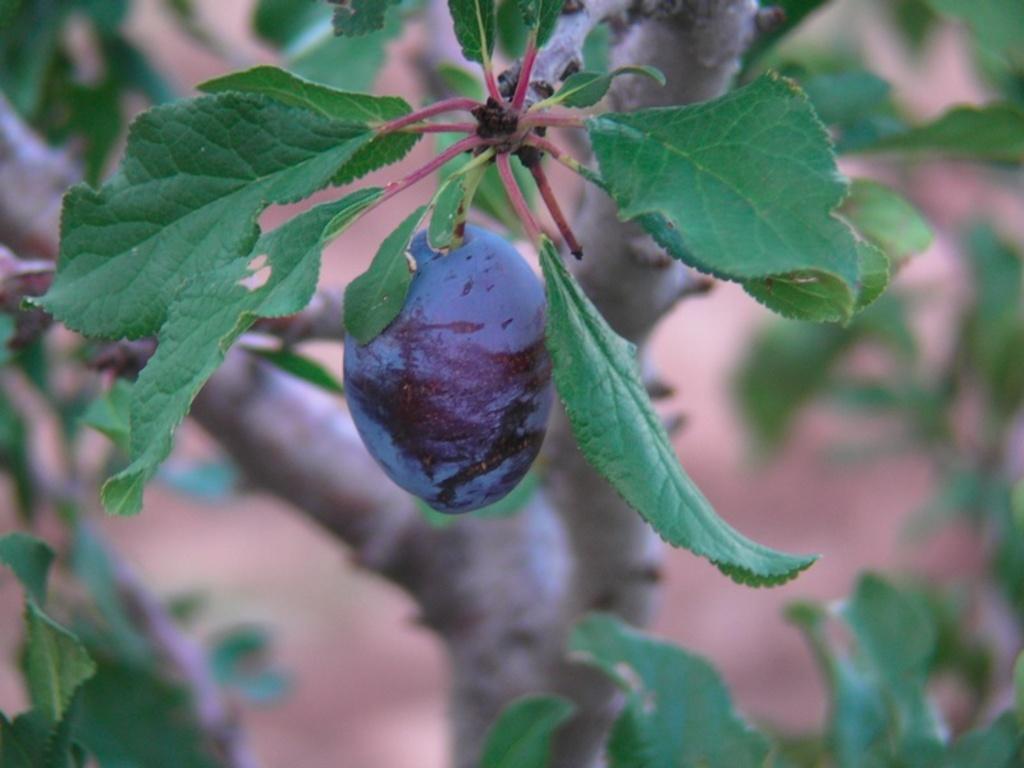Please provide a concise description of this image. This picture shows a tree and we see a fruit to it. 